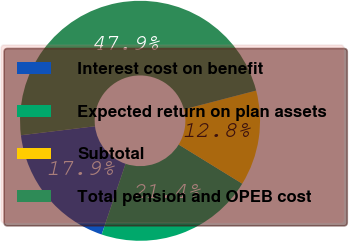Convert chart to OTSL. <chart><loc_0><loc_0><loc_500><loc_500><pie_chart><fcel>Interest cost on benefit<fcel>Expected return on plan assets<fcel>Subtotal<fcel>Total pension and OPEB cost<nl><fcel>17.9%<fcel>21.4%<fcel>12.83%<fcel>47.87%<nl></chart> 